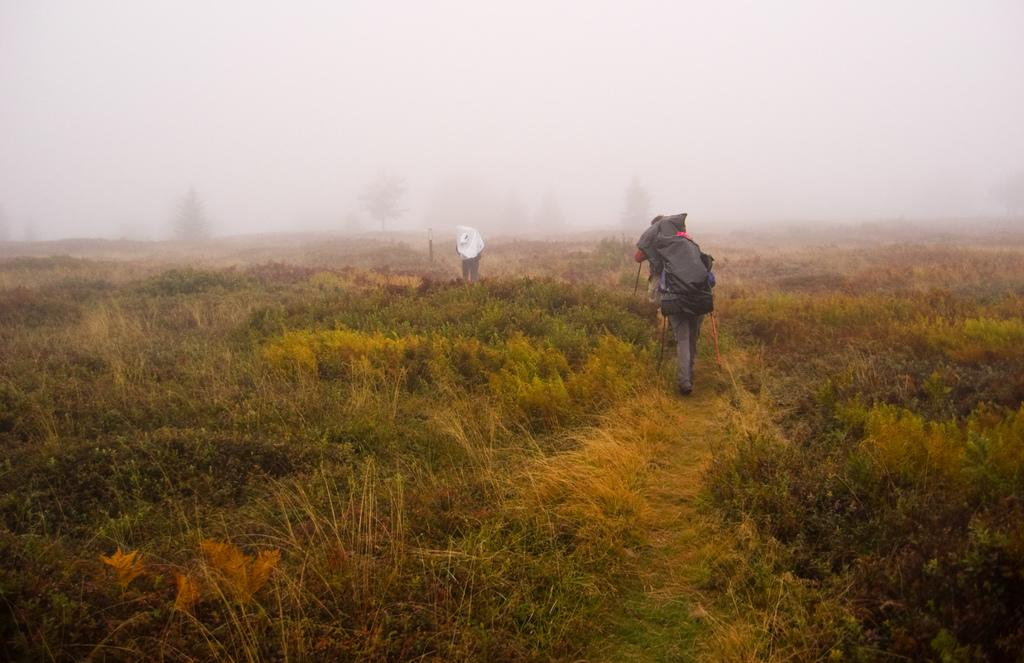What are the people in the image doing? The people in the image are walking. Can you describe what one of the people is carrying? One person is carrying a backpack. What type of terrain is visible at the bottom of the image? There is grass at the bottom of the image. What atmospheric condition can be seen in the image? There is fog visible in the image. What can be seen in the background of the image? There are trees in the background of the image. What type of harmony is being discussed by the committee in the image? There is no committee present in the image, and therefore no discussion about harmony can be observed. What key is being played by the musical instrument in the image? There is no musical instrument present in the image. 